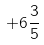<formula> <loc_0><loc_0><loc_500><loc_500>+ 6 \frac { 3 } { 5 }</formula> 